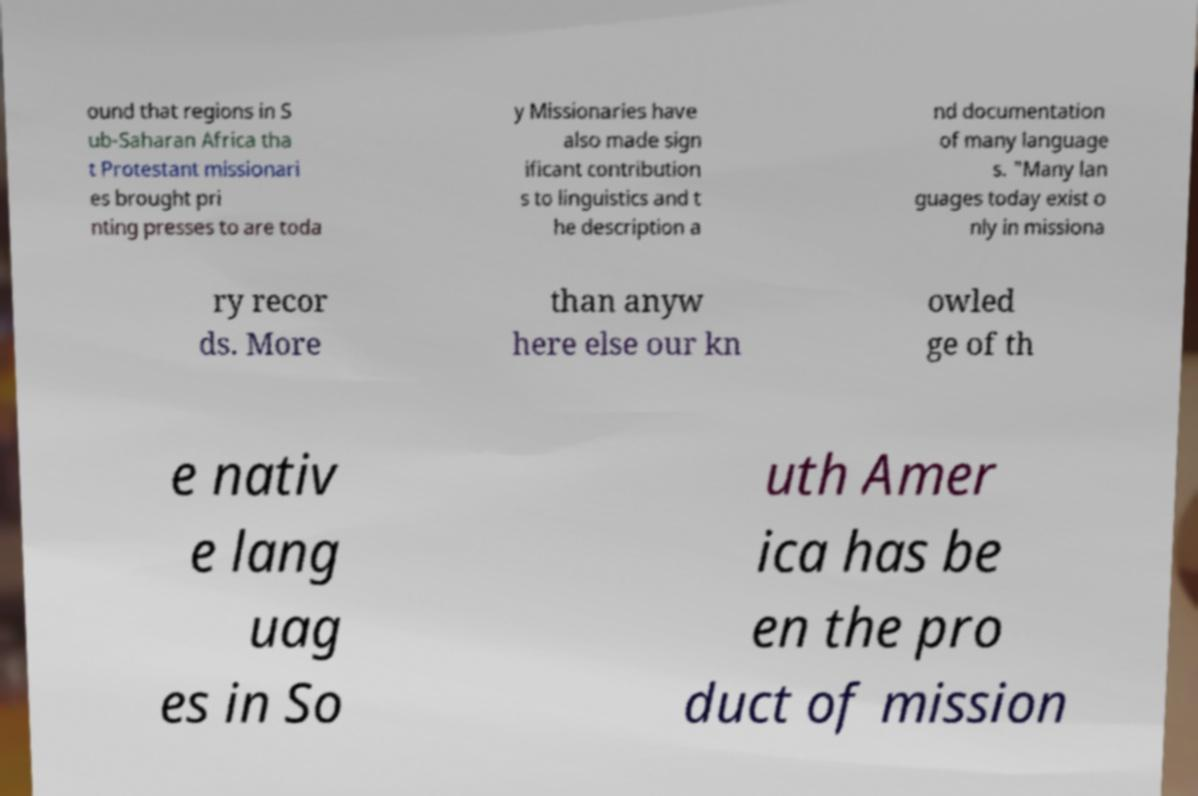Could you extract and type out the text from this image? ound that regions in S ub-Saharan Africa tha t Protestant missionari es brought pri nting presses to are toda y Missionaries have also made sign ificant contribution s to linguistics and t he description a nd documentation of many language s. "Many lan guages today exist o nly in missiona ry recor ds. More than anyw here else our kn owled ge of th e nativ e lang uag es in So uth Amer ica has be en the pro duct of mission 